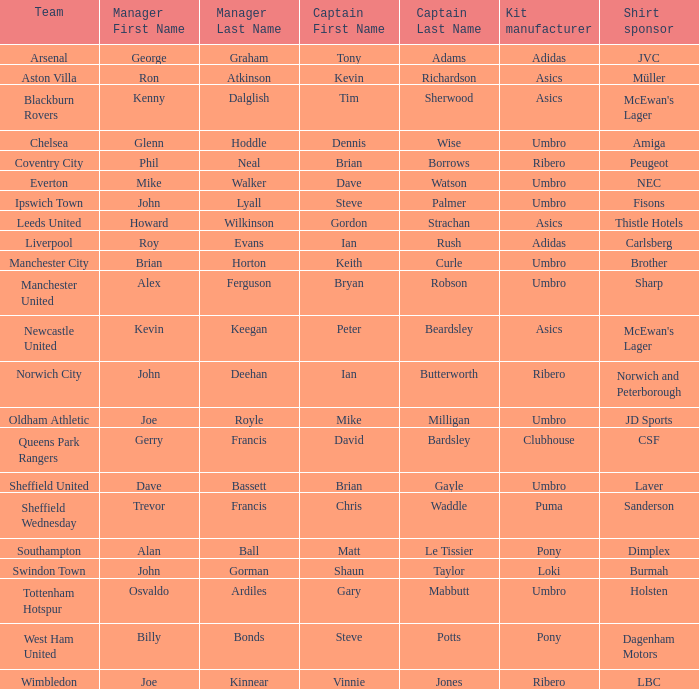Which captain has billy bonds as the manager? Steve Potts. 